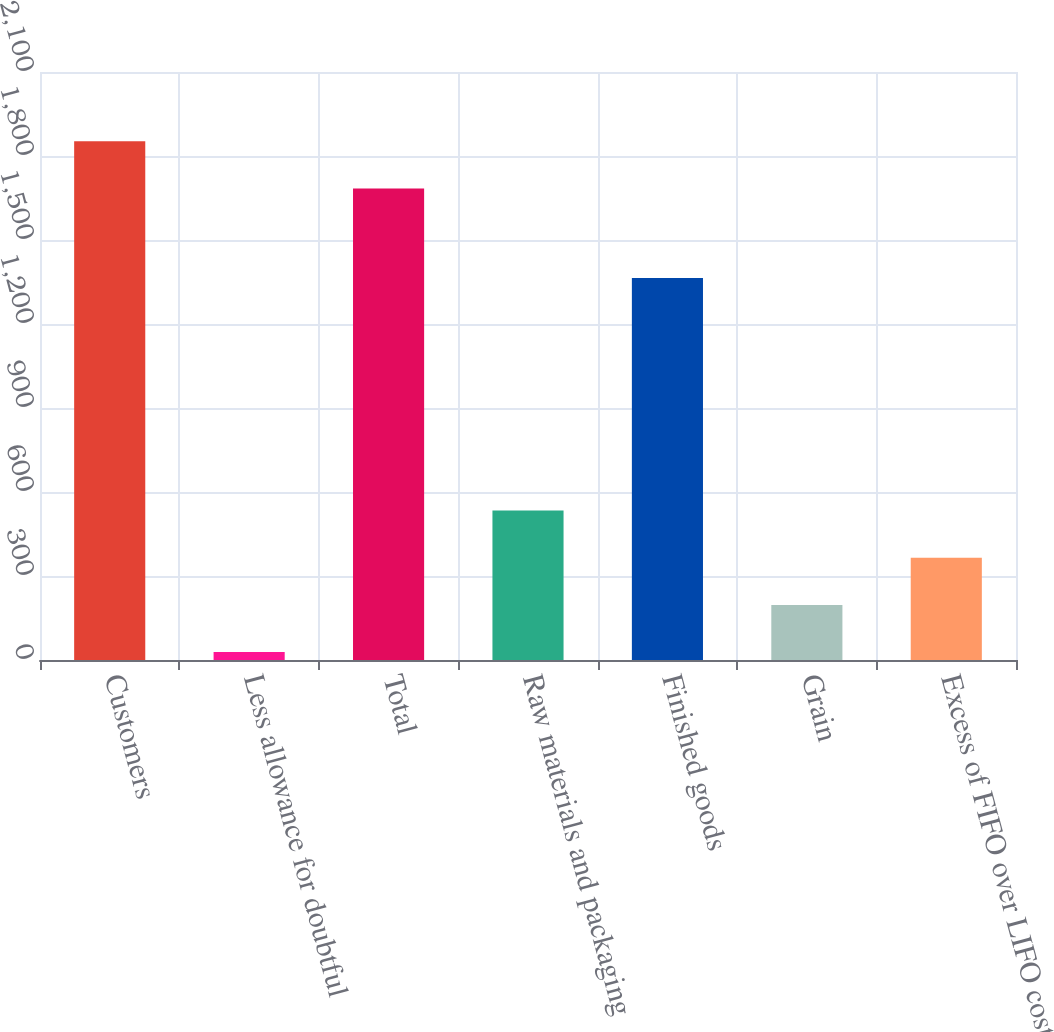Convert chart. <chart><loc_0><loc_0><loc_500><loc_500><bar_chart><fcel>Customers<fcel>Less allowance for doubtful<fcel>Total<fcel>Raw materials and packaging<fcel>Finished goods<fcel>Grain<fcel>Excess of FIFO over LIFO cost<nl><fcel>1852.62<fcel>28.4<fcel>1684.2<fcel>533.66<fcel>1364.2<fcel>196.82<fcel>365.24<nl></chart> 